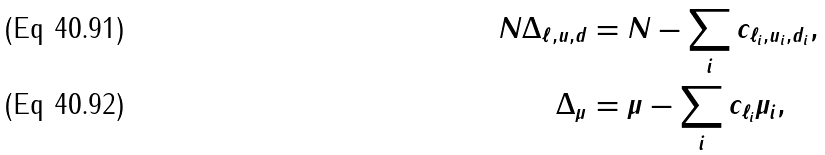Convert formula to latex. <formula><loc_0><loc_0><loc_500><loc_500>N \Delta _ { \ell , u , d } & = N - \sum _ { i } c _ { \ell _ { i } , u _ { i } , d _ { i } } , \\ \Delta _ { \mu } & = \mu - \sum _ { i } c _ { \ell _ { i } } \mu _ { i } ,</formula> 